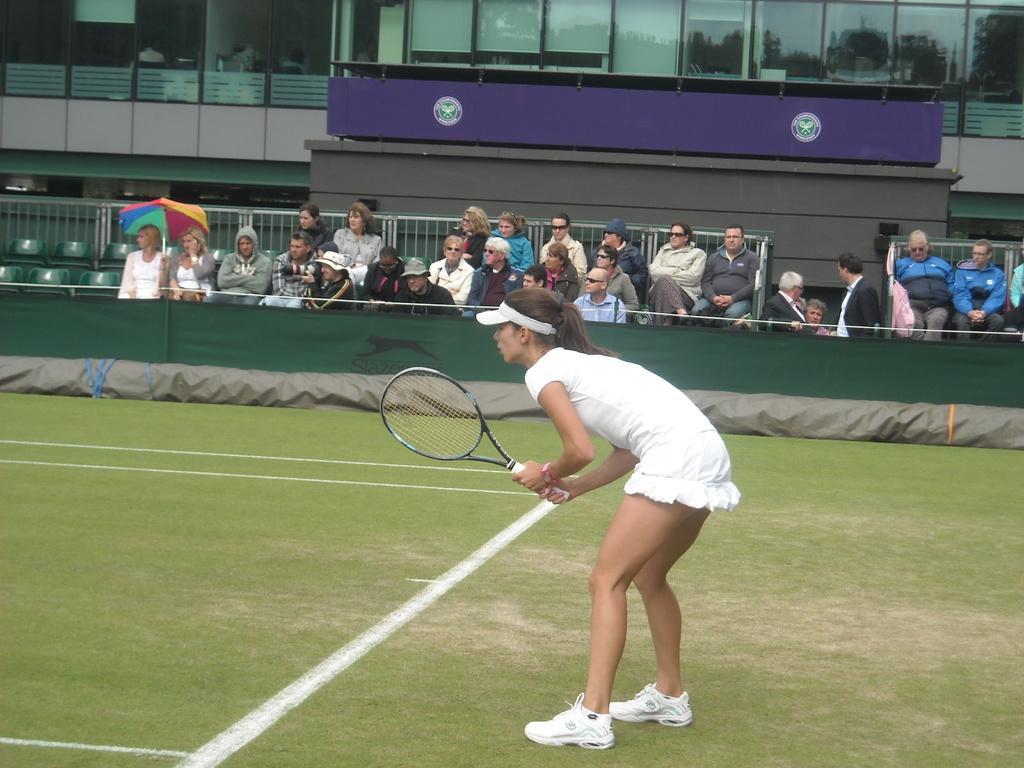Describe this image in one or two sentences. in the center we can see one woman standing and holding racket. In the background there is a wall,glass and group of persons were sitting on the chair and one person holding umbrella. 